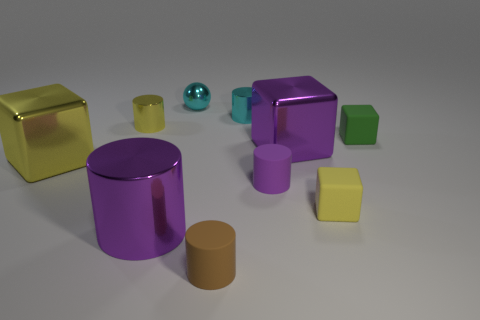Subtract 1 cylinders. How many cylinders are left? 4 Subtract all gray cylinders. Subtract all green blocks. How many cylinders are left? 5 Subtract all balls. How many objects are left? 9 Add 7 purple metallic cylinders. How many purple metallic cylinders exist? 8 Subtract 0 red cylinders. How many objects are left? 10 Subtract all tiny gray shiny objects. Subtract all large blocks. How many objects are left? 8 Add 7 small purple objects. How many small purple objects are left? 8 